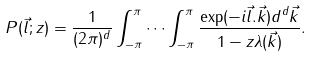<formula> <loc_0><loc_0><loc_500><loc_500>P ( { \vec { l } } ; z ) = \frac { 1 } { ( 2 \pi ) ^ { d } } \int _ { - \pi } ^ { \pi } \cdots \int _ { - \pi } ^ { \pi } \frac { \exp ( - i { \vec { l } } . { \vec { k } } ) d ^ { d } { \vec { k } } } { 1 - z \lambda ( { \vec { k } } ) } .</formula> 